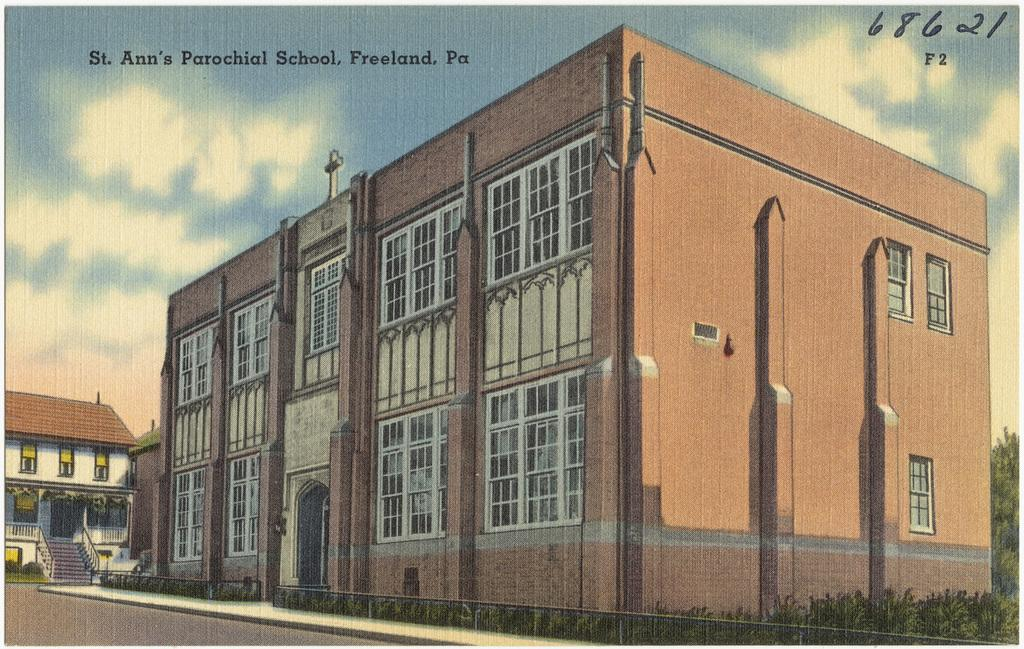<image>
Provide a brief description of the given image. St. Ann's Parochial School is located in Freeland, Pennsylvania. 